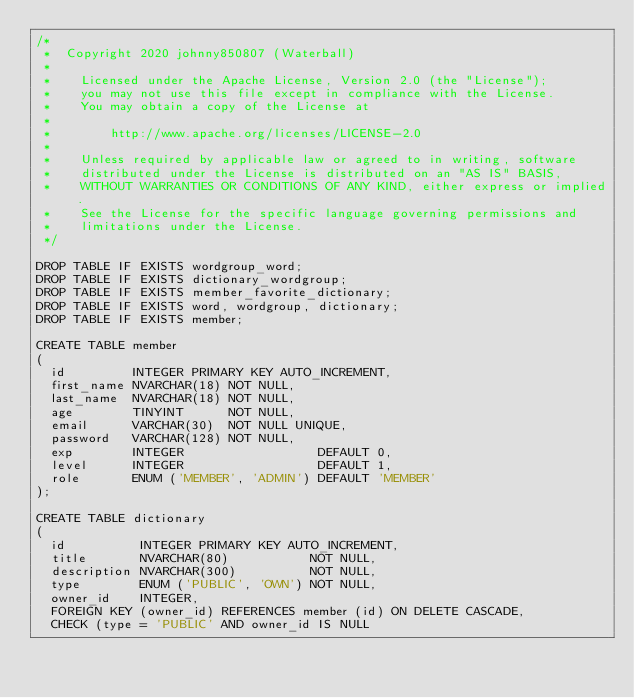Convert code to text. <code><loc_0><loc_0><loc_500><loc_500><_SQL_>/*
 *  Copyright 2020 johnny850807 (Waterball)
 *
 *    Licensed under the Apache License, Version 2.0 (the "License");
 *    you may not use this file except in compliance with the License.
 *    You may obtain a copy of the License at
 *
 *        http://www.apache.org/licenses/LICENSE-2.0
 *
 *    Unless required by applicable law or agreed to in writing, software
 *    distributed under the License is distributed on an "AS IS" BASIS,
 *    WITHOUT WARRANTIES OR CONDITIONS OF ANY KIND, either express or implied.
 *    See the License for the specific language governing permissions and
 *    limitations under the License.
 */

DROP TABLE IF EXISTS wordgroup_word;
DROP TABLE IF EXISTS dictionary_wordgroup;
DROP TABLE IF EXISTS member_favorite_dictionary;
DROP TABLE IF EXISTS word, wordgroup, dictionary;
DROP TABLE IF EXISTS member;

CREATE TABLE member
(
  id         INTEGER PRIMARY KEY AUTO_INCREMENT,
  first_name NVARCHAR(18) NOT NULL,
  last_name  NVARCHAR(18) NOT NULL,
  age        TINYINT      NOT NULL,
  email      VARCHAR(30)  NOT NULL UNIQUE,
  password   VARCHAR(128) NOT NULL,
  exp        INTEGER                  DEFAULT 0,
  level      INTEGER                  DEFAULT 1,
  role       ENUM ('MEMBER', 'ADMIN') DEFAULT 'MEMBER'
);

CREATE TABLE dictionary
(
  id          INTEGER PRIMARY KEY AUTO_INCREMENT,
  title       NVARCHAR(80)           NOT NULL,
  description NVARCHAR(300)          NOT NULL,
  type        ENUM ('PUBLIC', 'OWN') NOT NULL,
  owner_id    INTEGER,
  FOREIGN KEY (owner_id) REFERENCES member (id) ON DELETE CASCADE,
  CHECK (type = 'PUBLIC' AND owner_id IS NULL</code> 